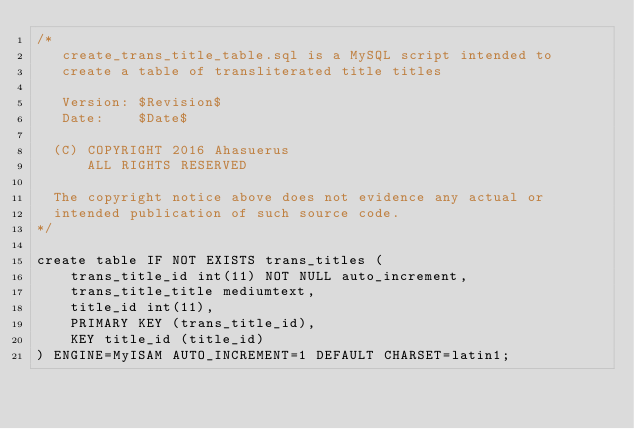Convert code to text. <code><loc_0><loc_0><loc_500><loc_500><_SQL_>/* 
   create_trans_title_table.sql is a MySQL script intended to
   create a table of transliterated title titles

   Version: $Revision$
   Date:    $Date$

  (C) COPYRIGHT 2016 Ahasuerus
      ALL RIGHTS RESERVED

  The copyright notice above does not evidence any actual or
  intended publication of such source code.
*/

create table IF NOT EXISTS trans_titles (
	trans_title_id int(11) NOT NULL auto_increment,
	trans_title_title mediumtext,
	title_id int(11),
	PRIMARY KEY (trans_title_id),
	KEY title_id (title_id)
) ENGINE=MyISAM AUTO_INCREMENT=1 DEFAULT CHARSET=latin1;
</code> 